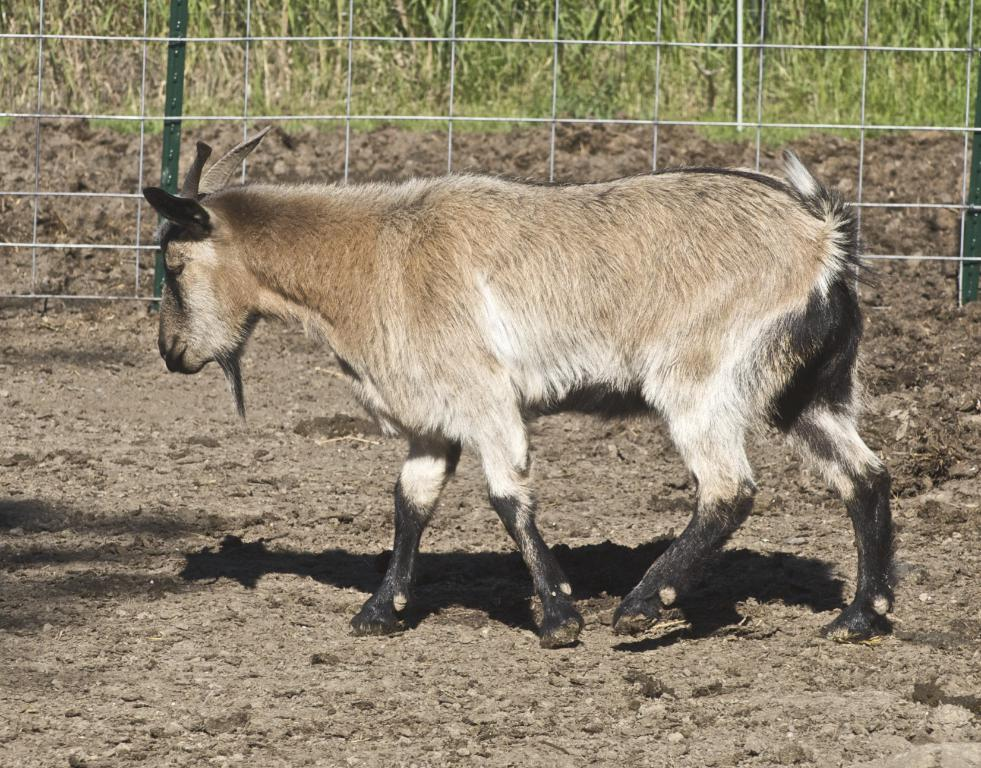What animal can be seen in the image? There is a goat in the image. What is the goat's position in the image? The goat is standing on the ground. What can be seen in the background of the image? There is fencing and bushes in the background of the image. What else can be observed on the ground in the image? Shadows are visible on the ground. What type of door can be seen in the image? There is no door present in the image; it features a goat standing on the ground with fencing and bushes in the background. 